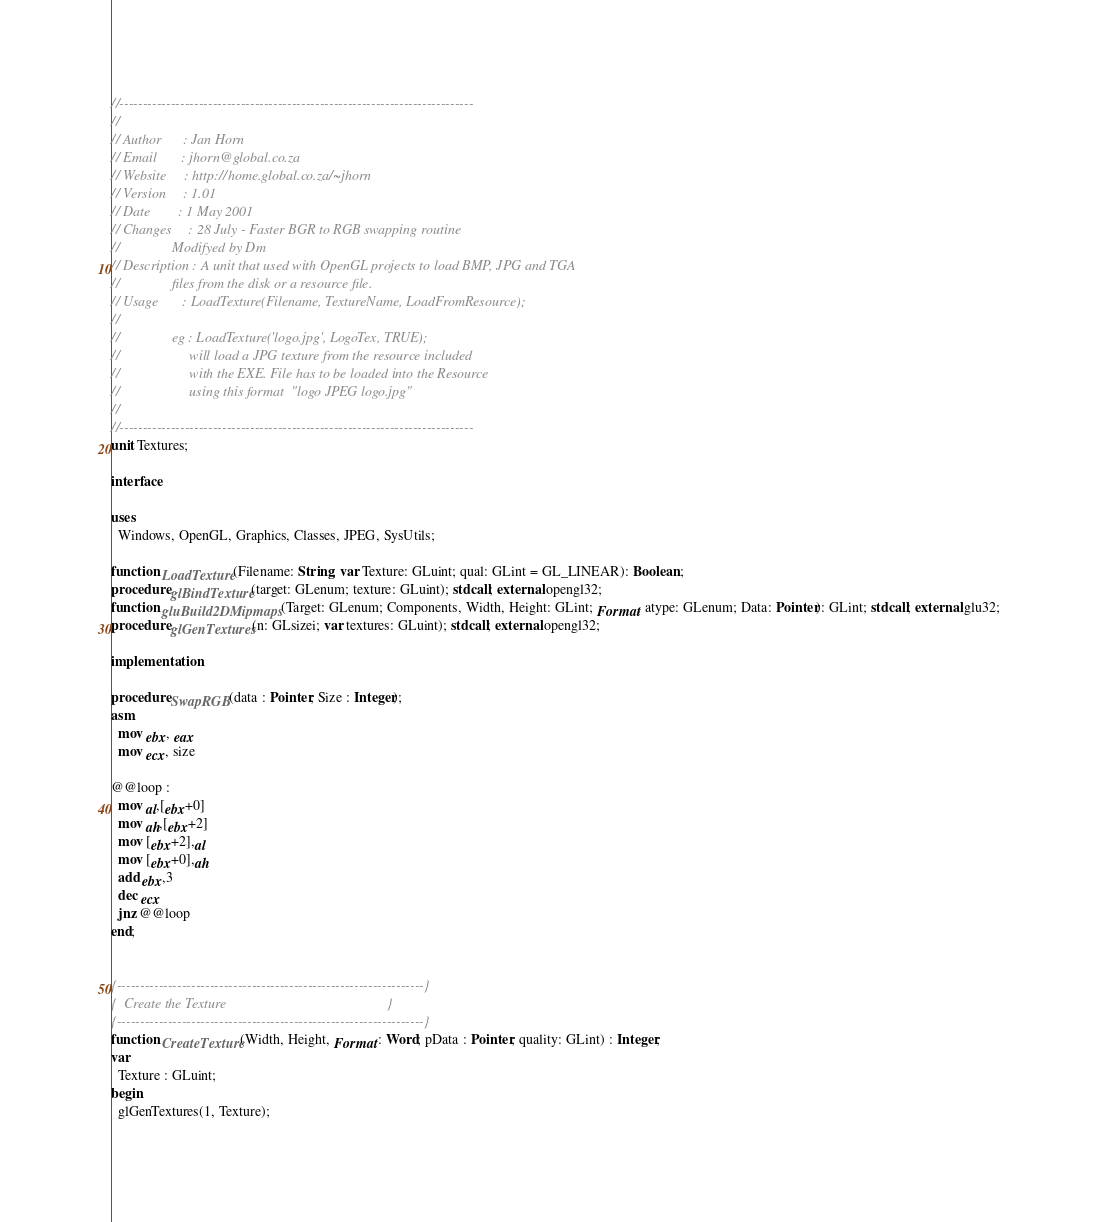Convert code to text. <code><loc_0><loc_0><loc_500><loc_500><_Pascal_>//----------------------------------------------------------------------------
//
// Author      : Jan Horn
// Email       : jhorn@global.co.za
// Website     : http://home.global.co.za/~jhorn
// Version     : 1.01
// Date        : 1 May 2001
// Changes     : 28 July - Faster BGR to RGB swapping routine
//               Modifyed by Dm
// Description : A unit that used with OpenGL projects to load BMP, JPG and TGA
//               files from the disk or a resource file.
// Usage       : LoadTexture(Filename, TextureName, LoadFromResource);
//
//               eg : LoadTexture('logo.jpg', LogoTex, TRUE);
//                    will load a JPG texture from the resource included
//                    with the EXE. File has to be loaded into the Resource
//                    using this format  "logo JPEG logo.jpg"
//
//----------------------------------------------------------------------------
unit Textures;

interface

uses
  Windows, OpenGL, Graphics, Classes, JPEG, SysUtils;

function LoadTexture(Filename: String; var Texture: GLuint; qual: GLint = GL_LINEAR): Boolean;
procedure glBindTexture(target: GLenum; texture: GLuint); stdcall; external opengl32;
function gluBuild2DMipmaps(Target: GLenum; Components, Width, Height: GLint; Format, atype: GLenum; Data: Pointer): GLint; stdcall; external glu32;
procedure glGenTextures(n: GLsizei; var textures: GLuint); stdcall; external opengl32;

implementation

procedure SwapRGB(data : Pointer; Size : Integer);
asm
  mov ebx, eax
  mov ecx, size

@@loop :
  mov al,[ebx+0]
  mov ah,[ebx+2]
  mov [ebx+2],al
  mov [ebx+0],ah
  add ebx,3
  dec ecx
  jnz @@loop
end;


{------------------------------------------------------------------}
{  Create the Texture                                              }
{------------------------------------------------------------------}
function CreateTexture(Width, Height, Format : Word; pData : Pointer; quality: GLint) : Integer;
var
  Texture : GLuint;
begin
  glGenTextures(1, Texture);</code> 